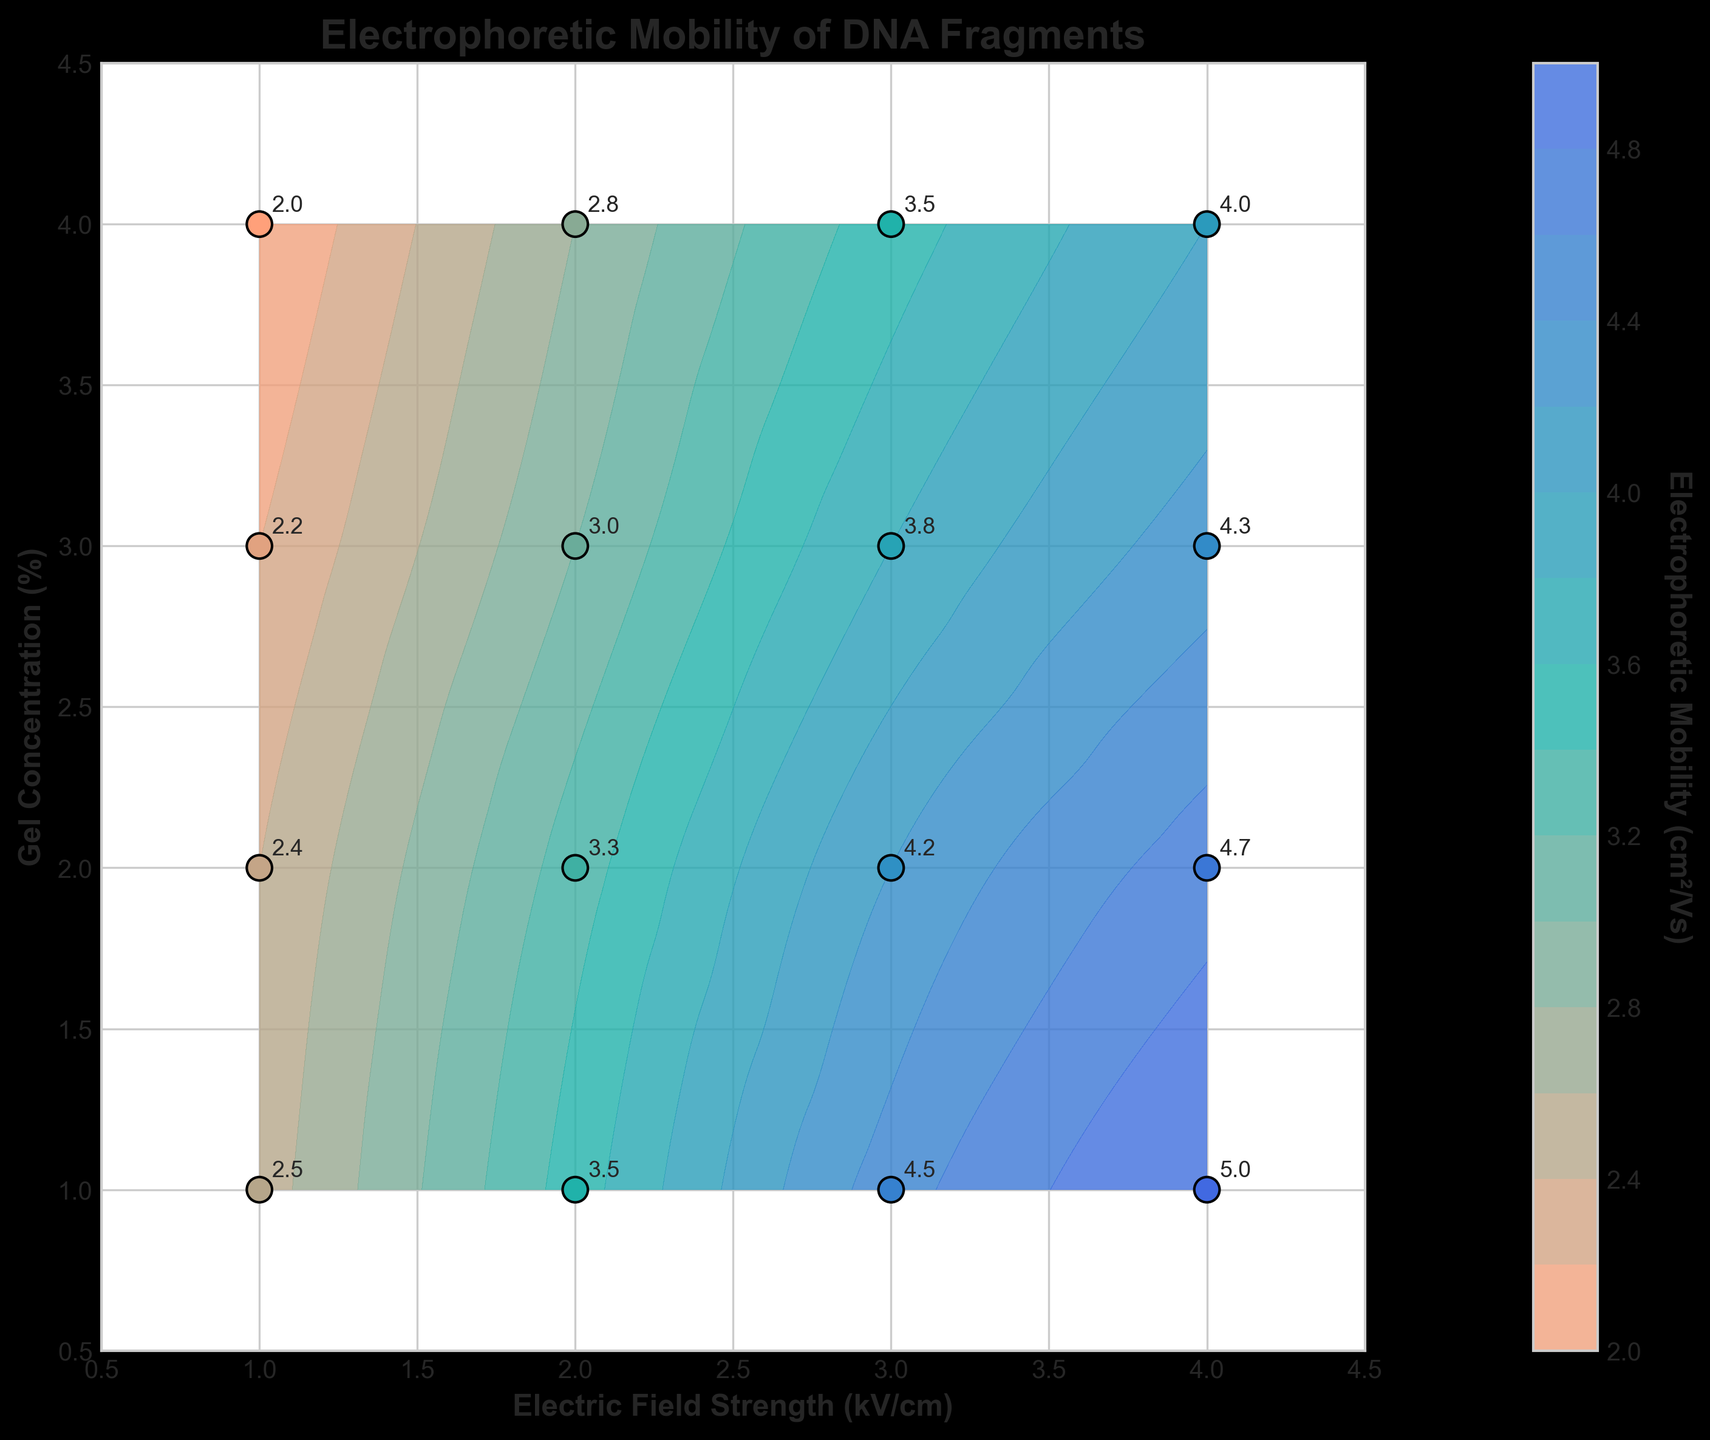What is the title of the figure? The title of the figure is located at the top and is in bold. It states 'Electrophoretic Mobility of DNA Fragments'.
Answer: Electrophoretic Mobility of DNA Fragments What are the labels of the x-axis and y-axis? The x-axis label is located below the horizontal axis and reads 'Electric Field Strength (kV/cm)'. The y-axis label is located to the left of the vertical axis and reads 'Gel Concentration (%)'.
Answer: Electric Field Strength (kV/cm) and Gel Concentration (%) How many data points are labeled in the figure? By counting the number of annotated data points with values on the scatter plot, we can see there are 16 different data points.
Answer: 16 Which data point shows the highest electrophoretic mobility, and what are its electric field strength and gel concentration? Locate the highest numbered annotation on the plot. The data point with 5.0 cm²/Vs is at an electric field strength of 4.0 kV/cm and a gel concentration of 1.0%.
Answer: 4.0 kV/cm, 1.0% How does the electrophoretic mobility change with increasing electric field strength at a constant gel concentration of 3.0%? Follow the line where the gel concentration is constant at 3.0%. The values for electrophoretic mobility increase from 2.2 to 4.3 as the electric field strength increases.
Answer: Increases What is the trend in electrophoretic mobility as gel concentration increases from 1.0% to 4.0% at a constant electric field strength of 3.0 kV/cm? Look at the data points along the line where the electric field strength is constant at 3.0 kV/cm. The electrophoretic mobility decreases progressively from 4.5 to 3.5 cm²/Vs as the gel concentration increases.
Answer: Decreases Compare the electrophoretic mobility at an electric field strength of 2.0 kV/cm with the same gel concentration of 2.0% and 4.0%. Which one is higher? Check the data points for 2.0 kV/cm along 2.0% and 4.0% gel concentrations. The values are 3.3 cm²/Vs and 2.8 cm²/Vs, respectively, so 3.3 is higher.
Answer: 2.0% gel concentration What is the difference in electrophoretic mobility between the data points at (1.0 kV/cm, 1.0%) and (4.0 kV/cm, 4.0%)? Find the values for these two coordinates. The values are 2.5 cm²/Vs and 4.0 cm²/Vs, respectively. The difference is 4.0 - 2.5 = 1.5 cm²/Vs.
Answer: 1.5 cm²/Vs Which combination of electric field strength and gel concentration results in the lowest electrophoretic mobility shown in the figure? Locate the smallest annotated value in the plot. The lowest value 2.0 cm²/Vs is obtained at an electric field strength of 1.0 kV/cm and a gel concentration of 4.0%.
Answer: 1.0 kV/cm, 4.0% What can be inferred about the relationship between gel concentration and electrophoretic mobility across different electric field strengths? By observing all patterns and trends in the plot, it is visible that generally, as the gel concentration increases, the electrophoretic mobility decreases across all electric field strengths.
Answer: Mobility decreases with increasing gel concentration 